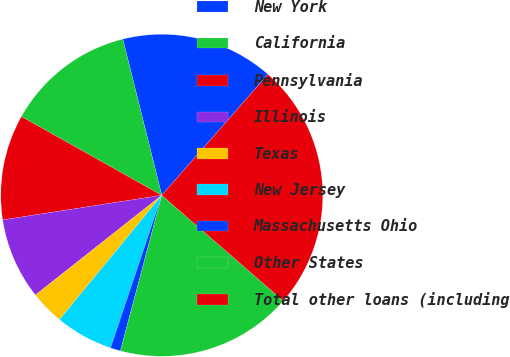<chart> <loc_0><loc_0><loc_500><loc_500><pie_chart><fcel>New York<fcel>California<fcel>Pennsylvania<fcel>Illinois<fcel>Texas<fcel>New Jersey<fcel>Massachusetts Ohio<fcel>Other States<fcel>Total other loans (including<nl><fcel>15.36%<fcel>12.97%<fcel>10.58%<fcel>8.19%<fcel>3.41%<fcel>5.8%<fcel>1.02%<fcel>17.75%<fcel>24.92%<nl></chart> 